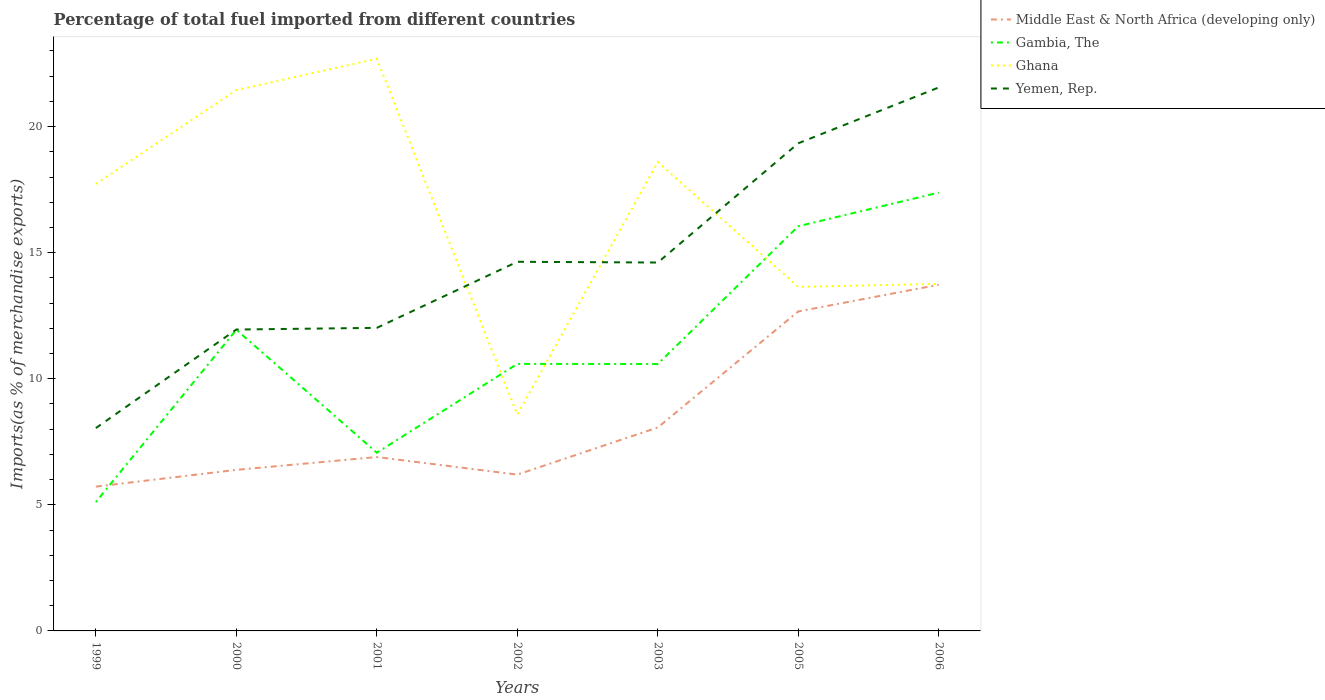Across all years, what is the maximum percentage of imports to different countries in Middle East & North Africa (developing only)?
Make the answer very short. 5.72. What is the total percentage of imports to different countries in Yemen, Rep. in the graph?
Your answer should be very brief. -0.07. What is the difference between the highest and the second highest percentage of imports to different countries in Gambia, The?
Your answer should be compact. 12.27. What is the difference between the highest and the lowest percentage of imports to different countries in Ghana?
Your answer should be compact. 4. How many lines are there?
Offer a very short reply. 4. Does the graph contain grids?
Your answer should be very brief. No. Where does the legend appear in the graph?
Provide a succinct answer. Top right. How many legend labels are there?
Ensure brevity in your answer.  4. What is the title of the graph?
Your answer should be very brief. Percentage of total fuel imported from different countries. Does "Lebanon" appear as one of the legend labels in the graph?
Keep it short and to the point. No. What is the label or title of the Y-axis?
Give a very brief answer. Imports(as % of merchandise exports). What is the Imports(as % of merchandise exports) of Middle East & North Africa (developing only) in 1999?
Offer a terse response. 5.72. What is the Imports(as % of merchandise exports) in Gambia, The in 1999?
Offer a terse response. 5.11. What is the Imports(as % of merchandise exports) in Ghana in 1999?
Keep it short and to the point. 17.73. What is the Imports(as % of merchandise exports) of Yemen, Rep. in 1999?
Keep it short and to the point. 8.04. What is the Imports(as % of merchandise exports) of Middle East & North Africa (developing only) in 2000?
Provide a short and direct response. 6.39. What is the Imports(as % of merchandise exports) in Gambia, The in 2000?
Make the answer very short. 11.94. What is the Imports(as % of merchandise exports) of Ghana in 2000?
Your response must be concise. 21.45. What is the Imports(as % of merchandise exports) of Yemen, Rep. in 2000?
Give a very brief answer. 11.95. What is the Imports(as % of merchandise exports) in Middle East & North Africa (developing only) in 2001?
Offer a very short reply. 6.9. What is the Imports(as % of merchandise exports) of Gambia, The in 2001?
Provide a succinct answer. 7.07. What is the Imports(as % of merchandise exports) in Ghana in 2001?
Your answer should be very brief. 22.69. What is the Imports(as % of merchandise exports) in Yemen, Rep. in 2001?
Provide a short and direct response. 12.02. What is the Imports(as % of merchandise exports) in Middle East & North Africa (developing only) in 2002?
Your answer should be compact. 6.2. What is the Imports(as % of merchandise exports) in Gambia, The in 2002?
Your answer should be compact. 10.59. What is the Imports(as % of merchandise exports) in Ghana in 2002?
Make the answer very short. 8.58. What is the Imports(as % of merchandise exports) in Yemen, Rep. in 2002?
Your answer should be very brief. 14.64. What is the Imports(as % of merchandise exports) of Middle East & North Africa (developing only) in 2003?
Ensure brevity in your answer.  8.07. What is the Imports(as % of merchandise exports) in Gambia, The in 2003?
Offer a very short reply. 10.59. What is the Imports(as % of merchandise exports) of Ghana in 2003?
Your answer should be compact. 18.6. What is the Imports(as % of merchandise exports) in Yemen, Rep. in 2003?
Make the answer very short. 14.61. What is the Imports(as % of merchandise exports) in Middle East & North Africa (developing only) in 2005?
Keep it short and to the point. 12.67. What is the Imports(as % of merchandise exports) in Gambia, The in 2005?
Keep it short and to the point. 16.05. What is the Imports(as % of merchandise exports) in Ghana in 2005?
Your answer should be very brief. 13.64. What is the Imports(as % of merchandise exports) in Yemen, Rep. in 2005?
Provide a succinct answer. 19.34. What is the Imports(as % of merchandise exports) in Middle East & North Africa (developing only) in 2006?
Provide a short and direct response. 13.73. What is the Imports(as % of merchandise exports) in Gambia, The in 2006?
Your answer should be compact. 17.38. What is the Imports(as % of merchandise exports) in Ghana in 2006?
Your answer should be very brief. 13.76. What is the Imports(as % of merchandise exports) in Yemen, Rep. in 2006?
Offer a very short reply. 21.55. Across all years, what is the maximum Imports(as % of merchandise exports) in Middle East & North Africa (developing only)?
Your response must be concise. 13.73. Across all years, what is the maximum Imports(as % of merchandise exports) in Gambia, The?
Give a very brief answer. 17.38. Across all years, what is the maximum Imports(as % of merchandise exports) in Ghana?
Offer a terse response. 22.69. Across all years, what is the maximum Imports(as % of merchandise exports) in Yemen, Rep.?
Your answer should be compact. 21.55. Across all years, what is the minimum Imports(as % of merchandise exports) in Middle East & North Africa (developing only)?
Make the answer very short. 5.72. Across all years, what is the minimum Imports(as % of merchandise exports) of Gambia, The?
Offer a terse response. 5.11. Across all years, what is the minimum Imports(as % of merchandise exports) in Ghana?
Give a very brief answer. 8.58. Across all years, what is the minimum Imports(as % of merchandise exports) in Yemen, Rep.?
Your answer should be compact. 8.04. What is the total Imports(as % of merchandise exports) of Middle East & North Africa (developing only) in the graph?
Offer a terse response. 59.68. What is the total Imports(as % of merchandise exports) in Gambia, The in the graph?
Offer a terse response. 78.73. What is the total Imports(as % of merchandise exports) of Ghana in the graph?
Your response must be concise. 116.45. What is the total Imports(as % of merchandise exports) of Yemen, Rep. in the graph?
Your answer should be very brief. 102.16. What is the difference between the Imports(as % of merchandise exports) of Middle East & North Africa (developing only) in 1999 and that in 2000?
Your response must be concise. -0.66. What is the difference between the Imports(as % of merchandise exports) of Gambia, The in 1999 and that in 2000?
Give a very brief answer. -6.83. What is the difference between the Imports(as % of merchandise exports) in Ghana in 1999 and that in 2000?
Give a very brief answer. -3.72. What is the difference between the Imports(as % of merchandise exports) of Yemen, Rep. in 1999 and that in 2000?
Keep it short and to the point. -3.91. What is the difference between the Imports(as % of merchandise exports) in Middle East & North Africa (developing only) in 1999 and that in 2001?
Offer a very short reply. -1.17. What is the difference between the Imports(as % of merchandise exports) of Gambia, The in 1999 and that in 2001?
Provide a succinct answer. -1.96. What is the difference between the Imports(as % of merchandise exports) of Ghana in 1999 and that in 2001?
Ensure brevity in your answer.  -4.97. What is the difference between the Imports(as % of merchandise exports) of Yemen, Rep. in 1999 and that in 2001?
Offer a very short reply. -3.97. What is the difference between the Imports(as % of merchandise exports) in Middle East & North Africa (developing only) in 1999 and that in 2002?
Ensure brevity in your answer.  -0.48. What is the difference between the Imports(as % of merchandise exports) in Gambia, The in 1999 and that in 2002?
Your answer should be compact. -5.48. What is the difference between the Imports(as % of merchandise exports) of Ghana in 1999 and that in 2002?
Offer a very short reply. 9.14. What is the difference between the Imports(as % of merchandise exports) of Yemen, Rep. in 1999 and that in 2002?
Offer a very short reply. -6.6. What is the difference between the Imports(as % of merchandise exports) in Middle East & North Africa (developing only) in 1999 and that in 2003?
Keep it short and to the point. -2.35. What is the difference between the Imports(as % of merchandise exports) in Gambia, The in 1999 and that in 2003?
Your response must be concise. -5.47. What is the difference between the Imports(as % of merchandise exports) in Ghana in 1999 and that in 2003?
Keep it short and to the point. -0.87. What is the difference between the Imports(as % of merchandise exports) in Yemen, Rep. in 1999 and that in 2003?
Provide a succinct answer. -6.57. What is the difference between the Imports(as % of merchandise exports) in Middle East & North Africa (developing only) in 1999 and that in 2005?
Provide a short and direct response. -6.95. What is the difference between the Imports(as % of merchandise exports) in Gambia, The in 1999 and that in 2005?
Make the answer very short. -10.94. What is the difference between the Imports(as % of merchandise exports) of Ghana in 1999 and that in 2005?
Give a very brief answer. 4.08. What is the difference between the Imports(as % of merchandise exports) in Yemen, Rep. in 1999 and that in 2005?
Your response must be concise. -11.3. What is the difference between the Imports(as % of merchandise exports) of Middle East & North Africa (developing only) in 1999 and that in 2006?
Keep it short and to the point. -8.01. What is the difference between the Imports(as % of merchandise exports) in Gambia, The in 1999 and that in 2006?
Your answer should be compact. -12.27. What is the difference between the Imports(as % of merchandise exports) in Ghana in 1999 and that in 2006?
Offer a very short reply. 3.96. What is the difference between the Imports(as % of merchandise exports) of Yemen, Rep. in 1999 and that in 2006?
Your answer should be very brief. -13.51. What is the difference between the Imports(as % of merchandise exports) in Middle East & North Africa (developing only) in 2000 and that in 2001?
Provide a succinct answer. -0.51. What is the difference between the Imports(as % of merchandise exports) of Gambia, The in 2000 and that in 2001?
Offer a terse response. 4.88. What is the difference between the Imports(as % of merchandise exports) in Ghana in 2000 and that in 2001?
Offer a very short reply. -1.24. What is the difference between the Imports(as % of merchandise exports) in Yemen, Rep. in 2000 and that in 2001?
Offer a terse response. -0.07. What is the difference between the Imports(as % of merchandise exports) in Middle East & North Africa (developing only) in 2000 and that in 2002?
Offer a very short reply. 0.19. What is the difference between the Imports(as % of merchandise exports) of Gambia, The in 2000 and that in 2002?
Provide a succinct answer. 1.35. What is the difference between the Imports(as % of merchandise exports) of Ghana in 2000 and that in 2002?
Your response must be concise. 12.87. What is the difference between the Imports(as % of merchandise exports) of Yemen, Rep. in 2000 and that in 2002?
Keep it short and to the point. -2.69. What is the difference between the Imports(as % of merchandise exports) in Middle East & North Africa (developing only) in 2000 and that in 2003?
Provide a short and direct response. -1.68. What is the difference between the Imports(as % of merchandise exports) in Gambia, The in 2000 and that in 2003?
Ensure brevity in your answer.  1.36. What is the difference between the Imports(as % of merchandise exports) of Ghana in 2000 and that in 2003?
Make the answer very short. 2.85. What is the difference between the Imports(as % of merchandise exports) of Yemen, Rep. in 2000 and that in 2003?
Offer a very short reply. -2.66. What is the difference between the Imports(as % of merchandise exports) in Middle East & North Africa (developing only) in 2000 and that in 2005?
Offer a terse response. -6.28. What is the difference between the Imports(as % of merchandise exports) of Gambia, The in 2000 and that in 2005?
Provide a short and direct response. -4.11. What is the difference between the Imports(as % of merchandise exports) of Ghana in 2000 and that in 2005?
Your answer should be compact. 7.8. What is the difference between the Imports(as % of merchandise exports) in Yemen, Rep. in 2000 and that in 2005?
Provide a succinct answer. -7.39. What is the difference between the Imports(as % of merchandise exports) of Middle East & North Africa (developing only) in 2000 and that in 2006?
Your response must be concise. -7.34. What is the difference between the Imports(as % of merchandise exports) in Gambia, The in 2000 and that in 2006?
Provide a succinct answer. -5.44. What is the difference between the Imports(as % of merchandise exports) of Ghana in 2000 and that in 2006?
Make the answer very short. 7.68. What is the difference between the Imports(as % of merchandise exports) of Yemen, Rep. in 2000 and that in 2006?
Keep it short and to the point. -9.6. What is the difference between the Imports(as % of merchandise exports) of Middle East & North Africa (developing only) in 2001 and that in 2002?
Make the answer very short. 0.7. What is the difference between the Imports(as % of merchandise exports) in Gambia, The in 2001 and that in 2002?
Offer a terse response. -3.52. What is the difference between the Imports(as % of merchandise exports) in Ghana in 2001 and that in 2002?
Your answer should be compact. 14.11. What is the difference between the Imports(as % of merchandise exports) in Yemen, Rep. in 2001 and that in 2002?
Your answer should be compact. -2.62. What is the difference between the Imports(as % of merchandise exports) of Middle East & North Africa (developing only) in 2001 and that in 2003?
Provide a short and direct response. -1.17. What is the difference between the Imports(as % of merchandise exports) of Gambia, The in 2001 and that in 2003?
Ensure brevity in your answer.  -3.52. What is the difference between the Imports(as % of merchandise exports) in Ghana in 2001 and that in 2003?
Provide a succinct answer. 4.1. What is the difference between the Imports(as % of merchandise exports) in Yemen, Rep. in 2001 and that in 2003?
Offer a very short reply. -2.59. What is the difference between the Imports(as % of merchandise exports) of Middle East & North Africa (developing only) in 2001 and that in 2005?
Offer a very short reply. -5.77. What is the difference between the Imports(as % of merchandise exports) of Gambia, The in 2001 and that in 2005?
Your answer should be very brief. -8.98. What is the difference between the Imports(as % of merchandise exports) in Ghana in 2001 and that in 2005?
Your response must be concise. 9.05. What is the difference between the Imports(as % of merchandise exports) of Yemen, Rep. in 2001 and that in 2005?
Give a very brief answer. -7.32. What is the difference between the Imports(as % of merchandise exports) in Middle East & North Africa (developing only) in 2001 and that in 2006?
Provide a succinct answer. -6.83. What is the difference between the Imports(as % of merchandise exports) of Gambia, The in 2001 and that in 2006?
Make the answer very short. -10.31. What is the difference between the Imports(as % of merchandise exports) in Ghana in 2001 and that in 2006?
Your answer should be very brief. 8.93. What is the difference between the Imports(as % of merchandise exports) in Yemen, Rep. in 2001 and that in 2006?
Your answer should be very brief. -9.53. What is the difference between the Imports(as % of merchandise exports) in Middle East & North Africa (developing only) in 2002 and that in 2003?
Your answer should be very brief. -1.87. What is the difference between the Imports(as % of merchandise exports) in Gambia, The in 2002 and that in 2003?
Keep it short and to the point. 0. What is the difference between the Imports(as % of merchandise exports) of Ghana in 2002 and that in 2003?
Your answer should be compact. -10.01. What is the difference between the Imports(as % of merchandise exports) in Yemen, Rep. in 2002 and that in 2003?
Provide a short and direct response. 0.03. What is the difference between the Imports(as % of merchandise exports) of Middle East & North Africa (developing only) in 2002 and that in 2005?
Give a very brief answer. -6.47. What is the difference between the Imports(as % of merchandise exports) in Gambia, The in 2002 and that in 2005?
Make the answer very short. -5.46. What is the difference between the Imports(as % of merchandise exports) in Ghana in 2002 and that in 2005?
Your answer should be very brief. -5.06. What is the difference between the Imports(as % of merchandise exports) of Yemen, Rep. in 2002 and that in 2005?
Ensure brevity in your answer.  -4.7. What is the difference between the Imports(as % of merchandise exports) of Middle East & North Africa (developing only) in 2002 and that in 2006?
Your response must be concise. -7.53. What is the difference between the Imports(as % of merchandise exports) of Gambia, The in 2002 and that in 2006?
Offer a terse response. -6.79. What is the difference between the Imports(as % of merchandise exports) in Ghana in 2002 and that in 2006?
Offer a very short reply. -5.18. What is the difference between the Imports(as % of merchandise exports) in Yemen, Rep. in 2002 and that in 2006?
Ensure brevity in your answer.  -6.91. What is the difference between the Imports(as % of merchandise exports) of Middle East & North Africa (developing only) in 2003 and that in 2005?
Your answer should be very brief. -4.6. What is the difference between the Imports(as % of merchandise exports) of Gambia, The in 2003 and that in 2005?
Give a very brief answer. -5.47. What is the difference between the Imports(as % of merchandise exports) of Ghana in 2003 and that in 2005?
Your answer should be compact. 4.95. What is the difference between the Imports(as % of merchandise exports) of Yemen, Rep. in 2003 and that in 2005?
Your response must be concise. -4.73. What is the difference between the Imports(as % of merchandise exports) in Middle East & North Africa (developing only) in 2003 and that in 2006?
Provide a succinct answer. -5.66. What is the difference between the Imports(as % of merchandise exports) of Gambia, The in 2003 and that in 2006?
Provide a short and direct response. -6.8. What is the difference between the Imports(as % of merchandise exports) in Ghana in 2003 and that in 2006?
Your answer should be very brief. 4.83. What is the difference between the Imports(as % of merchandise exports) of Yemen, Rep. in 2003 and that in 2006?
Your answer should be very brief. -6.94. What is the difference between the Imports(as % of merchandise exports) in Middle East & North Africa (developing only) in 2005 and that in 2006?
Provide a short and direct response. -1.06. What is the difference between the Imports(as % of merchandise exports) of Gambia, The in 2005 and that in 2006?
Make the answer very short. -1.33. What is the difference between the Imports(as % of merchandise exports) in Ghana in 2005 and that in 2006?
Make the answer very short. -0.12. What is the difference between the Imports(as % of merchandise exports) in Yemen, Rep. in 2005 and that in 2006?
Your response must be concise. -2.21. What is the difference between the Imports(as % of merchandise exports) in Middle East & North Africa (developing only) in 1999 and the Imports(as % of merchandise exports) in Gambia, The in 2000?
Your answer should be very brief. -6.22. What is the difference between the Imports(as % of merchandise exports) in Middle East & North Africa (developing only) in 1999 and the Imports(as % of merchandise exports) in Ghana in 2000?
Keep it short and to the point. -15.72. What is the difference between the Imports(as % of merchandise exports) in Middle East & North Africa (developing only) in 1999 and the Imports(as % of merchandise exports) in Yemen, Rep. in 2000?
Keep it short and to the point. -6.23. What is the difference between the Imports(as % of merchandise exports) in Gambia, The in 1999 and the Imports(as % of merchandise exports) in Ghana in 2000?
Give a very brief answer. -16.34. What is the difference between the Imports(as % of merchandise exports) in Gambia, The in 1999 and the Imports(as % of merchandise exports) in Yemen, Rep. in 2000?
Your answer should be very brief. -6.84. What is the difference between the Imports(as % of merchandise exports) of Ghana in 1999 and the Imports(as % of merchandise exports) of Yemen, Rep. in 2000?
Ensure brevity in your answer.  5.77. What is the difference between the Imports(as % of merchandise exports) of Middle East & North Africa (developing only) in 1999 and the Imports(as % of merchandise exports) of Gambia, The in 2001?
Your answer should be compact. -1.34. What is the difference between the Imports(as % of merchandise exports) of Middle East & North Africa (developing only) in 1999 and the Imports(as % of merchandise exports) of Ghana in 2001?
Give a very brief answer. -16.97. What is the difference between the Imports(as % of merchandise exports) of Middle East & North Africa (developing only) in 1999 and the Imports(as % of merchandise exports) of Yemen, Rep. in 2001?
Provide a short and direct response. -6.3. What is the difference between the Imports(as % of merchandise exports) in Gambia, The in 1999 and the Imports(as % of merchandise exports) in Ghana in 2001?
Give a very brief answer. -17.58. What is the difference between the Imports(as % of merchandise exports) of Gambia, The in 1999 and the Imports(as % of merchandise exports) of Yemen, Rep. in 2001?
Provide a succinct answer. -6.91. What is the difference between the Imports(as % of merchandise exports) in Ghana in 1999 and the Imports(as % of merchandise exports) in Yemen, Rep. in 2001?
Your response must be concise. 5.71. What is the difference between the Imports(as % of merchandise exports) of Middle East & North Africa (developing only) in 1999 and the Imports(as % of merchandise exports) of Gambia, The in 2002?
Offer a very short reply. -4.87. What is the difference between the Imports(as % of merchandise exports) in Middle East & North Africa (developing only) in 1999 and the Imports(as % of merchandise exports) in Ghana in 2002?
Give a very brief answer. -2.86. What is the difference between the Imports(as % of merchandise exports) of Middle East & North Africa (developing only) in 1999 and the Imports(as % of merchandise exports) of Yemen, Rep. in 2002?
Ensure brevity in your answer.  -8.92. What is the difference between the Imports(as % of merchandise exports) of Gambia, The in 1999 and the Imports(as % of merchandise exports) of Ghana in 2002?
Provide a short and direct response. -3.47. What is the difference between the Imports(as % of merchandise exports) of Gambia, The in 1999 and the Imports(as % of merchandise exports) of Yemen, Rep. in 2002?
Give a very brief answer. -9.53. What is the difference between the Imports(as % of merchandise exports) of Ghana in 1999 and the Imports(as % of merchandise exports) of Yemen, Rep. in 2002?
Provide a short and direct response. 3.09. What is the difference between the Imports(as % of merchandise exports) in Middle East & North Africa (developing only) in 1999 and the Imports(as % of merchandise exports) in Gambia, The in 2003?
Provide a succinct answer. -4.86. What is the difference between the Imports(as % of merchandise exports) in Middle East & North Africa (developing only) in 1999 and the Imports(as % of merchandise exports) in Ghana in 2003?
Give a very brief answer. -12.87. What is the difference between the Imports(as % of merchandise exports) of Middle East & North Africa (developing only) in 1999 and the Imports(as % of merchandise exports) of Yemen, Rep. in 2003?
Your response must be concise. -8.89. What is the difference between the Imports(as % of merchandise exports) in Gambia, The in 1999 and the Imports(as % of merchandise exports) in Ghana in 2003?
Ensure brevity in your answer.  -13.48. What is the difference between the Imports(as % of merchandise exports) in Gambia, The in 1999 and the Imports(as % of merchandise exports) in Yemen, Rep. in 2003?
Offer a very short reply. -9.5. What is the difference between the Imports(as % of merchandise exports) of Ghana in 1999 and the Imports(as % of merchandise exports) of Yemen, Rep. in 2003?
Ensure brevity in your answer.  3.12. What is the difference between the Imports(as % of merchandise exports) in Middle East & North Africa (developing only) in 1999 and the Imports(as % of merchandise exports) in Gambia, The in 2005?
Keep it short and to the point. -10.33. What is the difference between the Imports(as % of merchandise exports) in Middle East & North Africa (developing only) in 1999 and the Imports(as % of merchandise exports) in Ghana in 2005?
Your response must be concise. -7.92. What is the difference between the Imports(as % of merchandise exports) in Middle East & North Africa (developing only) in 1999 and the Imports(as % of merchandise exports) in Yemen, Rep. in 2005?
Provide a succinct answer. -13.62. What is the difference between the Imports(as % of merchandise exports) in Gambia, The in 1999 and the Imports(as % of merchandise exports) in Ghana in 2005?
Offer a terse response. -8.53. What is the difference between the Imports(as % of merchandise exports) in Gambia, The in 1999 and the Imports(as % of merchandise exports) in Yemen, Rep. in 2005?
Ensure brevity in your answer.  -14.23. What is the difference between the Imports(as % of merchandise exports) in Ghana in 1999 and the Imports(as % of merchandise exports) in Yemen, Rep. in 2005?
Offer a terse response. -1.61. What is the difference between the Imports(as % of merchandise exports) in Middle East & North Africa (developing only) in 1999 and the Imports(as % of merchandise exports) in Gambia, The in 2006?
Make the answer very short. -11.66. What is the difference between the Imports(as % of merchandise exports) in Middle East & North Africa (developing only) in 1999 and the Imports(as % of merchandise exports) in Ghana in 2006?
Your answer should be very brief. -8.04. What is the difference between the Imports(as % of merchandise exports) in Middle East & North Africa (developing only) in 1999 and the Imports(as % of merchandise exports) in Yemen, Rep. in 2006?
Your response must be concise. -15.83. What is the difference between the Imports(as % of merchandise exports) of Gambia, The in 1999 and the Imports(as % of merchandise exports) of Ghana in 2006?
Keep it short and to the point. -8.65. What is the difference between the Imports(as % of merchandise exports) of Gambia, The in 1999 and the Imports(as % of merchandise exports) of Yemen, Rep. in 2006?
Offer a terse response. -16.44. What is the difference between the Imports(as % of merchandise exports) in Ghana in 1999 and the Imports(as % of merchandise exports) in Yemen, Rep. in 2006?
Provide a succinct answer. -3.83. What is the difference between the Imports(as % of merchandise exports) in Middle East & North Africa (developing only) in 2000 and the Imports(as % of merchandise exports) in Gambia, The in 2001?
Your response must be concise. -0.68. What is the difference between the Imports(as % of merchandise exports) in Middle East & North Africa (developing only) in 2000 and the Imports(as % of merchandise exports) in Ghana in 2001?
Give a very brief answer. -16.3. What is the difference between the Imports(as % of merchandise exports) in Middle East & North Africa (developing only) in 2000 and the Imports(as % of merchandise exports) in Yemen, Rep. in 2001?
Your response must be concise. -5.63. What is the difference between the Imports(as % of merchandise exports) in Gambia, The in 2000 and the Imports(as % of merchandise exports) in Ghana in 2001?
Keep it short and to the point. -10.75. What is the difference between the Imports(as % of merchandise exports) in Gambia, The in 2000 and the Imports(as % of merchandise exports) in Yemen, Rep. in 2001?
Your answer should be compact. -0.08. What is the difference between the Imports(as % of merchandise exports) in Ghana in 2000 and the Imports(as % of merchandise exports) in Yemen, Rep. in 2001?
Offer a very short reply. 9.43. What is the difference between the Imports(as % of merchandise exports) of Middle East & North Africa (developing only) in 2000 and the Imports(as % of merchandise exports) of Gambia, The in 2002?
Make the answer very short. -4.2. What is the difference between the Imports(as % of merchandise exports) of Middle East & North Africa (developing only) in 2000 and the Imports(as % of merchandise exports) of Ghana in 2002?
Give a very brief answer. -2.19. What is the difference between the Imports(as % of merchandise exports) in Middle East & North Africa (developing only) in 2000 and the Imports(as % of merchandise exports) in Yemen, Rep. in 2002?
Offer a terse response. -8.25. What is the difference between the Imports(as % of merchandise exports) in Gambia, The in 2000 and the Imports(as % of merchandise exports) in Ghana in 2002?
Make the answer very short. 3.36. What is the difference between the Imports(as % of merchandise exports) of Gambia, The in 2000 and the Imports(as % of merchandise exports) of Yemen, Rep. in 2002?
Your answer should be compact. -2.7. What is the difference between the Imports(as % of merchandise exports) in Ghana in 2000 and the Imports(as % of merchandise exports) in Yemen, Rep. in 2002?
Offer a very short reply. 6.81. What is the difference between the Imports(as % of merchandise exports) in Middle East & North Africa (developing only) in 2000 and the Imports(as % of merchandise exports) in Gambia, The in 2003?
Provide a succinct answer. -4.2. What is the difference between the Imports(as % of merchandise exports) of Middle East & North Africa (developing only) in 2000 and the Imports(as % of merchandise exports) of Ghana in 2003?
Provide a short and direct response. -12.21. What is the difference between the Imports(as % of merchandise exports) in Middle East & North Africa (developing only) in 2000 and the Imports(as % of merchandise exports) in Yemen, Rep. in 2003?
Ensure brevity in your answer.  -8.22. What is the difference between the Imports(as % of merchandise exports) in Gambia, The in 2000 and the Imports(as % of merchandise exports) in Ghana in 2003?
Give a very brief answer. -6.65. What is the difference between the Imports(as % of merchandise exports) in Gambia, The in 2000 and the Imports(as % of merchandise exports) in Yemen, Rep. in 2003?
Provide a succinct answer. -2.67. What is the difference between the Imports(as % of merchandise exports) of Ghana in 2000 and the Imports(as % of merchandise exports) of Yemen, Rep. in 2003?
Offer a very short reply. 6.84. What is the difference between the Imports(as % of merchandise exports) in Middle East & North Africa (developing only) in 2000 and the Imports(as % of merchandise exports) in Gambia, The in 2005?
Make the answer very short. -9.66. What is the difference between the Imports(as % of merchandise exports) of Middle East & North Africa (developing only) in 2000 and the Imports(as % of merchandise exports) of Ghana in 2005?
Make the answer very short. -7.26. What is the difference between the Imports(as % of merchandise exports) of Middle East & North Africa (developing only) in 2000 and the Imports(as % of merchandise exports) of Yemen, Rep. in 2005?
Ensure brevity in your answer.  -12.95. What is the difference between the Imports(as % of merchandise exports) of Gambia, The in 2000 and the Imports(as % of merchandise exports) of Ghana in 2005?
Keep it short and to the point. -1.7. What is the difference between the Imports(as % of merchandise exports) in Gambia, The in 2000 and the Imports(as % of merchandise exports) in Yemen, Rep. in 2005?
Ensure brevity in your answer.  -7.4. What is the difference between the Imports(as % of merchandise exports) in Ghana in 2000 and the Imports(as % of merchandise exports) in Yemen, Rep. in 2005?
Provide a short and direct response. 2.11. What is the difference between the Imports(as % of merchandise exports) of Middle East & North Africa (developing only) in 2000 and the Imports(as % of merchandise exports) of Gambia, The in 2006?
Your answer should be compact. -10.99. What is the difference between the Imports(as % of merchandise exports) of Middle East & North Africa (developing only) in 2000 and the Imports(as % of merchandise exports) of Ghana in 2006?
Make the answer very short. -7.38. What is the difference between the Imports(as % of merchandise exports) of Middle East & North Africa (developing only) in 2000 and the Imports(as % of merchandise exports) of Yemen, Rep. in 2006?
Offer a terse response. -15.17. What is the difference between the Imports(as % of merchandise exports) of Gambia, The in 2000 and the Imports(as % of merchandise exports) of Ghana in 2006?
Keep it short and to the point. -1.82. What is the difference between the Imports(as % of merchandise exports) of Gambia, The in 2000 and the Imports(as % of merchandise exports) of Yemen, Rep. in 2006?
Give a very brief answer. -9.61. What is the difference between the Imports(as % of merchandise exports) in Ghana in 2000 and the Imports(as % of merchandise exports) in Yemen, Rep. in 2006?
Provide a succinct answer. -0.11. What is the difference between the Imports(as % of merchandise exports) in Middle East & North Africa (developing only) in 2001 and the Imports(as % of merchandise exports) in Gambia, The in 2002?
Make the answer very short. -3.69. What is the difference between the Imports(as % of merchandise exports) in Middle East & North Africa (developing only) in 2001 and the Imports(as % of merchandise exports) in Ghana in 2002?
Your response must be concise. -1.69. What is the difference between the Imports(as % of merchandise exports) of Middle East & North Africa (developing only) in 2001 and the Imports(as % of merchandise exports) of Yemen, Rep. in 2002?
Your answer should be very brief. -7.74. What is the difference between the Imports(as % of merchandise exports) in Gambia, The in 2001 and the Imports(as % of merchandise exports) in Ghana in 2002?
Keep it short and to the point. -1.51. What is the difference between the Imports(as % of merchandise exports) in Gambia, The in 2001 and the Imports(as % of merchandise exports) in Yemen, Rep. in 2002?
Your response must be concise. -7.57. What is the difference between the Imports(as % of merchandise exports) of Ghana in 2001 and the Imports(as % of merchandise exports) of Yemen, Rep. in 2002?
Offer a very short reply. 8.05. What is the difference between the Imports(as % of merchandise exports) of Middle East & North Africa (developing only) in 2001 and the Imports(as % of merchandise exports) of Gambia, The in 2003?
Provide a short and direct response. -3.69. What is the difference between the Imports(as % of merchandise exports) of Middle East & North Africa (developing only) in 2001 and the Imports(as % of merchandise exports) of Ghana in 2003?
Ensure brevity in your answer.  -11.7. What is the difference between the Imports(as % of merchandise exports) of Middle East & North Africa (developing only) in 2001 and the Imports(as % of merchandise exports) of Yemen, Rep. in 2003?
Provide a succinct answer. -7.71. What is the difference between the Imports(as % of merchandise exports) of Gambia, The in 2001 and the Imports(as % of merchandise exports) of Ghana in 2003?
Offer a terse response. -11.53. What is the difference between the Imports(as % of merchandise exports) of Gambia, The in 2001 and the Imports(as % of merchandise exports) of Yemen, Rep. in 2003?
Give a very brief answer. -7.54. What is the difference between the Imports(as % of merchandise exports) of Ghana in 2001 and the Imports(as % of merchandise exports) of Yemen, Rep. in 2003?
Offer a terse response. 8.08. What is the difference between the Imports(as % of merchandise exports) in Middle East & North Africa (developing only) in 2001 and the Imports(as % of merchandise exports) in Gambia, The in 2005?
Your answer should be very brief. -9.15. What is the difference between the Imports(as % of merchandise exports) of Middle East & North Africa (developing only) in 2001 and the Imports(as % of merchandise exports) of Ghana in 2005?
Your answer should be very brief. -6.75. What is the difference between the Imports(as % of merchandise exports) of Middle East & North Africa (developing only) in 2001 and the Imports(as % of merchandise exports) of Yemen, Rep. in 2005?
Keep it short and to the point. -12.44. What is the difference between the Imports(as % of merchandise exports) in Gambia, The in 2001 and the Imports(as % of merchandise exports) in Ghana in 2005?
Offer a terse response. -6.58. What is the difference between the Imports(as % of merchandise exports) in Gambia, The in 2001 and the Imports(as % of merchandise exports) in Yemen, Rep. in 2005?
Offer a very short reply. -12.27. What is the difference between the Imports(as % of merchandise exports) of Ghana in 2001 and the Imports(as % of merchandise exports) of Yemen, Rep. in 2005?
Keep it short and to the point. 3.35. What is the difference between the Imports(as % of merchandise exports) of Middle East & North Africa (developing only) in 2001 and the Imports(as % of merchandise exports) of Gambia, The in 2006?
Provide a short and direct response. -10.49. What is the difference between the Imports(as % of merchandise exports) of Middle East & North Africa (developing only) in 2001 and the Imports(as % of merchandise exports) of Ghana in 2006?
Make the answer very short. -6.87. What is the difference between the Imports(as % of merchandise exports) in Middle East & North Africa (developing only) in 2001 and the Imports(as % of merchandise exports) in Yemen, Rep. in 2006?
Ensure brevity in your answer.  -14.66. What is the difference between the Imports(as % of merchandise exports) in Gambia, The in 2001 and the Imports(as % of merchandise exports) in Ghana in 2006?
Provide a short and direct response. -6.7. What is the difference between the Imports(as % of merchandise exports) in Gambia, The in 2001 and the Imports(as % of merchandise exports) in Yemen, Rep. in 2006?
Your response must be concise. -14.49. What is the difference between the Imports(as % of merchandise exports) in Ghana in 2001 and the Imports(as % of merchandise exports) in Yemen, Rep. in 2006?
Ensure brevity in your answer.  1.14. What is the difference between the Imports(as % of merchandise exports) of Middle East & North Africa (developing only) in 2002 and the Imports(as % of merchandise exports) of Gambia, The in 2003?
Your answer should be very brief. -4.39. What is the difference between the Imports(as % of merchandise exports) of Middle East & North Africa (developing only) in 2002 and the Imports(as % of merchandise exports) of Ghana in 2003?
Provide a succinct answer. -12.4. What is the difference between the Imports(as % of merchandise exports) in Middle East & North Africa (developing only) in 2002 and the Imports(as % of merchandise exports) in Yemen, Rep. in 2003?
Your answer should be very brief. -8.41. What is the difference between the Imports(as % of merchandise exports) in Gambia, The in 2002 and the Imports(as % of merchandise exports) in Ghana in 2003?
Offer a very short reply. -8.01. What is the difference between the Imports(as % of merchandise exports) in Gambia, The in 2002 and the Imports(as % of merchandise exports) in Yemen, Rep. in 2003?
Offer a terse response. -4.02. What is the difference between the Imports(as % of merchandise exports) in Ghana in 2002 and the Imports(as % of merchandise exports) in Yemen, Rep. in 2003?
Your answer should be compact. -6.03. What is the difference between the Imports(as % of merchandise exports) of Middle East & North Africa (developing only) in 2002 and the Imports(as % of merchandise exports) of Gambia, The in 2005?
Make the answer very short. -9.85. What is the difference between the Imports(as % of merchandise exports) in Middle East & North Africa (developing only) in 2002 and the Imports(as % of merchandise exports) in Ghana in 2005?
Provide a succinct answer. -7.44. What is the difference between the Imports(as % of merchandise exports) of Middle East & North Africa (developing only) in 2002 and the Imports(as % of merchandise exports) of Yemen, Rep. in 2005?
Your answer should be compact. -13.14. What is the difference between the Imports(as % of merchandise exports) in Gambia, The in 2002 and the Imports(as % of merchandise exports) in Ghana in 2005?
Offer a terse response. -3.05. What is the difference between the Imports(as % of merchandise exports) in Gambia, The in 2002 and the Imports(as % of merchandise exports) in Yemen, Rep. in 2005?
Your response must be concise. -8.75. What is the difference between the Imports(as % of merchandise exports) in Ghana in 2002 and the Imports(as % of merchandise exports) in Yemen, Rep. in 2005?
Your response must be concise. -10.76. What is the difference between the Imports(as % of merchandise exports) of Middle East & North Africa (developing only) in 2002 and the Imports(as % of merchandise exports) of Gambia, The in 2006?
Provide a short and direct response. -11.18. What is the difference between the Imports(as % of merchandise exports) of Middle East & North Africa (developing only) in 2002 and the Imports(as % of merchandise exports) of Ghana in 2006?
Offer a terse response. -7.56. What is the difference between the Imports(as % of merchandise exports) in Middle East & North Africa (developing only) in 2002 and the Imports(as % of merchandise exports) in Yemen, Rep. in 2006?
Make the answer very short. -15.35. What is the difference between the Imports(as % of merchandise exports) of Gambia, The in 2002 and the Imports(as % of merchandise exports) of Ghana in 2006?
Offer a terse response. -3.17. What is the difference between the Imports(as % of merchandise exports) in Gambia, The in 2002 and the Imports(as % of merchandise exports) in Yemen, Rep. in 2006?
Ensure brevity in your answer.  -10.96. What is the difference between the Imports(as % of merchandise exports) of Ghana in 2002 and the Imports(as % of merchandise exports) of Yemen, Rep. in 2006?
Keep it short and to the point. -12.97. What is the difference between the Imports(as % of merchandise exports) in Middle East & North Africa (developing only) in 2003 and the Imports(as % of merchandise exports) in Gambia, The in 2005?
Your response must be concise. -7.98. What is the difference between the Imports(as % of merchandise exports) in Middle East & North Africa (developing only) in 2003 and the Imports(as % of merchandise exports) in Ghana in 2005?
Make the answer very short. -5.57. What is the difference between the Imports(as % of merchandise exports) of Middle East & North Africa (developing only) in 2003 and the Imports(as % of merchandise exports) of Yemen, Rep. in 2005?
Give a very brief answer. -11.27. What is the difference between the Imports(as % of merchandise exports) in Gambia, The in 2003 and the Imports(as % of merchandise exports) in Ghana in 2005?
Provide a short and direct response. -3.06. What is the difference between the Imports(as % of merchandise exports) in Gambia, The in 2003 and the Imports(as % of merchandise exports) in Yemen, Rep. in 2005?
Make the answer very short. -8.76. What is the difference between the Imports(as % of merchandise exports) of Ghana in 2003 and the Imports(as % of merchandise exports) of Yemen, Rep. in 2005?
Keep it short and to the point. -0.74. What is the difference between the Imports(as % of merchandise exports) of Middle East & North Africa (developing only) in 2003 and the Imports(as % of merchandise exports) of Gambia, The in 2006?
Keep it short and to the point. -9.31. What is the difference between the Imports(as % of merchandise exports) of Middle East & North Africa (developing only) in 2003 and the Imports(as % of merchandise exports) of Ghana in 2006?
Provide a succinct answer. -5.69. What is the difference between the Imports(as % of merchandise exports) in Middle East & North Africa (developing only) in 2003 and the Imports(as % of merchandise exports) in Yemen, Rep. in 2006?
Your response must be concise. -13.48. What is the difference between the Imports(as % of merchandise exports) in Gambia, The in 2003 and the Imports(as % of merchandise exports) in Ghana in 2006?
Provide a succinct answer. -3.18. What is the difference between the Imports(as % of merchandise exports) of Gambia, The in 2003 and the Imports(as % of merchandise exports) of Yemen, Rep. in 2006?
Provide a succinct answer. -10.97. What is the difference between the Imports(as % of merchandise exports) of Ghana in 2003 and the Imports(as % of merchandise exports) of Yemen, Rep. in 2006?
Provide a short and direct response. -2.96. What is the difference between the Imports(as % of merchandise exports) in Middle East & North Africa (developing only) in 2005 and the Imports(as % of merchandise exports) in Gambia, The in 2006?
Offer a terse response. -4.71. What is the difference between the Imports(as % of merchandise exports) of Middle East & North Africa (developing only) in 2005 and the Imports(as % of merchandise exports) of Ghana in 2006?
Keep it short and to the point. -1.09. What is the difference between the Imports(as % of merchandise exports) of Middle East & North Africa (developing only) in 2005 and the Imports(as % of merchandise exports) of Yemen, Rep. in 2006?
Offer a terse response. -8.88. What is the difference between the Imports(as % of merchandise exports) of Gambia, The in 2005 and the Imports(as % of merchandise exports) of Ghana in 2006?
Give a very brief answer. 2.29. What is the difference between the Imports(as % of merchandise exports) in Gambia, The in 2005 and the Imports(as % of merchandise exports) in Yemen, Rep. in 2006?
Your response must be concise. -5.5. What is the difference between the Imports(as % of merchandise exports) of Ghana in 2005 and the Imports(as % of merchandise exports) of Yemen, Rep. in 2006?
Your answer should be compact. -7.91. What is the average Imports(as % of merchandise exports) in Middle East & North Africa (developing only) per year?
Your answer should be very brief. 8.53. What is the average Imports(as % of merchandise exports) of Gambia, The per year?
Make the answer very short. 11.25. What is the average Imports(as % of merchandise exports) in Ghana per year?
Offer a terse response. 16.64. What is the average Imports(as % of merchandise exports) of Yemen, Rep. per year?
Give a very brief answer. 14.59. In the year 1999, what is the difference between the Imports(as % of merchandise exports) in Middle East & North Africa (developing only) and Imports(as % of merchandise exports) in Gambia, The?
Keep it short and to the point. 0.61. In the year 1999, what is the difference between the Imports(as % of merchandise exports) of Middle East & North Africa (developing only) and Imports(as % of merchandise exports) of Ghana?
Ensure brevity in your answer.  -12. In the year 1999, what is the difference between the Imports(as % of merchandise exports) in Middle East & North Africa (developing only) and Imports(as % of merchandise exports) in Yemen, Rep.?
Provide a succinct answer. -2.32. In the year 1999, what is the difference between the Imports(as % of merchandise exports) of Gambia, The and Imports(as % of merchandise exports) of Ghana?
Offer a very short reply. -12.61. In the year 1999, what is the difference between the Imports(as % of merchandise exports) in Gambia, The and Imports(as % of merchandise exports) in Yemen, Rep.?
Make the answer very short. -2.93. In the year 1999, what is the difference between the Imports(as % of merchandise exports) in Ghana and Imports(as % of merchandise exports) in Yemen, Rep.?
Make the answer very short. 9.68. In the year 2000, what is the difference between the Imports(as % of merchandise exports) in Middle East & North Africa (developing only) and Imports(as % of merchandise exports) in Gambia, The?
Provide a succinct answer. -5.56. In the year 2000, what is the difference between the Imports(as % of merchandise exports) in Middle East & North Africa (developing only) and Imports(as % of merchandise exports) in Ghana?
Give a very brief answer. -15.06. In the year 2000, what is the difference between the Imports(as % of merchandise exports) in Middle East & North Africa (developing only) and Imports(as % of merchandise exports) in Yemen, Rep.?
Your answer should be compact. -5.57. In the year 2000, what is the difference between the Imports(as % of merchandise exports) of Gambia, The and Imports(as % of merchandise exports) of Ghana?
Your answer should be compact. -9.5. In the year 2000, what is the difference between the Imports(as % of merchandise exports) in Gambia, The and Imports(as % of merchandise exports) in Yemen, Rep.?
Your response must be concise. -0.01. In the year 2000, what is the difference between the Imports(as % of merchandise exports) in Ghana and Imports(as % of merchandise exports) in Yemen, Rep.?
Offer a very short reply. 9.49. In the year 2001, what is the difference between the Imports(as % of merchandise exports) of Middle East & North Africa (developing only) and Imports(as % of merchandise exports) of Gambia, The?
Keep it short and to the point. -0.17. In the year 2001, what is the difference between the Imports(as % of merchandise exports) in Middle East & North Africa (developing only) and Imports(as % of merchandise exports) in Ghana?
Your answer should be compact. -15.8. In the year 2001, what is the difference between the Imports(as % of merchandise exports) in Middle East & North Africa (developing only) and Imports(as % of merchandise exports) in Yemen, Rep.?
Your answer should be compact. -5.12. In the year 2001, what is the difference between the Imports(as % of merchandise exports) in Gambia, The and Imports(as % of merchandise exports) in Ghana?
Provide a succinct answer. -15.62. In the year 2001, what is the difference between the Imports(as % of merchandise exports) in Gambia, The and Imports(as % of merchandise exports) in Yemen, Rep.?
Ensure brevity in your answer.  -4.95. In the year 2001, what is the difference between the Imports(as % of merchandise exports) in Ghana and Imports(as % of merchandise exports) in Yemen, Rep.?
Offer a very short reply. 10.67. In the year 2002, what is the difference between the Imports(as % of merchandise exports) in Middle East & North Africa (developing only) and Imports(as % of merchandise exports) in Gambia, The?
Your answer should be compact. -4.39. In the year 2002, what is the difference between the Imports(as % of merchandise exports) of Middle East & North Africa (developing only) and Imports(as % of merchandise exports) of Ghana?
Provide a succinct answer. -2.38. In the year 2002, what is the difference between the Imports(as % of merchandise exports) in Middle East & North Africa (developing only) and Imports(as % of merchandise exports) in Yemen, Rep.?
Offer a terse response. -8.44. In the year 2002, what is the difference between the Imports(as % of merchandise exports) of Gambia, The and Imports(as % of merchandise exports) of Ghana?
Your answer should be very brief. 2.01. In the year 2002, what is the difference between the Imports(as % of merchandise exports) of Gambia, The and Imports(as % of merchandise exports) of Yemen, Rep.?
Make the answer very short. -4.05. In the year 2002, what is the difference between the Imports(as % of merchandise exports) in Ghana and Imports(as % of merchandise exports) in Yemen, Rep.?
Your response must be concise. -6.06. In the year 2003, what is the difference between the Imports(as % of merchandise exports) in Middle East & North Africa (developing only) and Imports(as % of merchandise exports) in Gambia, The?
Provide a short and direct response. -2.52. In the year 2003, what is the difference between the Imports(as % of merchandise exports) in Middle East & North Africa (developing only) and Imports(as % of merchandise exports) in Ghana?
Your answer should be very brief. -10.53. In the year 2003, what is the difference between the Imports(as % of merchandise exports) in Middle East & North Africa (developing only) and Imports(as % of merchandise exports) in Yemen, Rep.?
Your answer should be compact. -6.54. In the year 2003, what is the difference between the Imports(as % of merchandise exports) of Gambia, The and Imports(as % of merchandise exports) of Ghana?
Your response must be concise. -8.01. In the year 2003, what is the difference between the Imports(as % of merchandise exports) of Gambia, The and Imports(as % of merchandise exports) of Yemen, Rep.?
Give a very brief answer. -4.03. In the year 2003, what is the difference between the Imports(as % of merchandise exports) in Ghana and Imports(as % of merchandise exports) in Yemen, Rep.?
Offer a very short reply. 3.99. In the year 2005, what is the difference between the Imports(as % of merchandise exports) in Middle East & North Africa (developing only) and Imports(as % of merchandise exports) in Gambia, The?
Ensure brevity in your answer.  -3.38. In the year 2005, what is the difference between the Imports(as % of merchandise exports) of Middle East & North Africa (developing only) and Imports(as % of merchandise exports) of Ghana?
Provide a short and direct response. -0.97. In the year 2005, what is the difference between the Imports(as % of merchandise exports) in Middle East & North Africa (developing only) and Imports(as % of merchandise exports) in Yemen, Rep.?
Your response must be concise. -6.67. In the year 2005, what is the difference between the Imports(as % of merchandise exports) of Gambia, The and Imports(as % of merchandise exports) of Ghana?
Give a very brief answer. 2.41. In the year 2005, what is the difference between the Imports(as % of merchandise exports) of Gambia, The and Imports(as % of merchandise exports) of Yemen, Rep.?
Keep it short and to the point. -3.29. In the year 2005, what is the difference between the Imports(as % of merchandise exports) of Ghana and Imports(as % of merchandise exports) of Yemen, Rep.?
Offer a very short reply. -5.7. In the year 2006, what is the difference between the Imports(as % of merchandise exports) of Middle East & North Africa (developing only) and Imports(as % of merchandise exports) of Gambia, The?
Offer a very short reply. -3.65. In the year 2006, what is the difference between the Imports(as % of merchandise exports) in Middle East & North Africa (developing only) and Imports(as % of merchandise exports) in Ghana?
Your response must be concise. -0.03. In the year 2006, what is the difference between the Imports(as % of merchandise exports) in Middle East & North Africa (developing only) and Imports(as % of merchandise exports) in Yemen, Rep.?
Make the answer very short. -7.83. In the year 2006, what is the difference between the Imports(as % of merchandise exports) in Gambia, The and Imports(as % of merchandise exports) in Ghana?
Your response must be concise. 3.62. In the year 2006, what is the difference between the Imports(as % of merchandise exports) of Gambia, The and Imports(as % of merchandise exports) of Yemen, Rep.?
Offer a terse response. -4.17. In the year 2006, what is the difference between the Imports(as % of merchandise exports) in Ghana and Imports(as % of merchandise exports) in Yemen, Rep.?
Keep it short and to the point. -7.79. What is the ratio of the Imports(as % of merchandise exports) of Middle East & North Africa (developing only) in 1999 to that in 2000?
Ensure brevity in your answer.  0.9. What is the ratio of the Imports(as % of merchandise exports) of Gambia, The in 1999 to that in 2000?
Ensure brevity in your answer.  0.43. What is the ratio of the Imports(as % of merchandise exports) of Ghana in 1999 to that in 2000?
Provide a short and direct response. 0.83. What is the ratio of the Imports(as % of merchandise exports) in Yemen, Rep. in 1999 to that in 2000?
Make the answer very short. 0.67. What is the ratio of the Imports(as % of merchandise exports) in Middle East & North Africa (developing only) in 1999 to that in 2001?
Keep it short and to the point. 0.83. What is the ratio of the Imports(as % of merchandise exports) of Gambia, The in 1999 to that in 2001?
Your response must be concise. 0.72. What is the ratio of the Imports(as % of merchandise exports) of Ghana in 1999 to that in 2001?
Make the answer very short. 0.78. What is the ratio of the Imports(as % of merchandise exports) in Yemen, Rep. in 1999 to that in 2001?
Ensure brevity in your answer.  0.67. What is the ratio of the Imports(as % of merchandise exports) of Middle East & North Africa (developing only) in 1999 to that in 2002?
Provide a succinct answer. 0.92. What is the ratio of the Imports(as % of merchandise exports) of Gambia, The in 1999 to that in 2002?
Ensure brevity in your answer.  0.48. What is the ratio of the Imports(as % of merchandise exports) of Ghana in 1999 to that in 2002?
Your answer should be compact. 2.07. What is the ratio of the Imports(as % of merchandise exports) of Yemen, Rep. in 1999 to that in 2002?
Keep it short and to the point. 0.55. What is the ratio of the Imports(as % of merchandise exports) of Middle East & North Africa (developing only) in 1999 to that in 2003?
Offer a very short reply. 0.71. What is the ratio of the Imports(as % of merchandise exports) in Gambia, The in 1999 to that in 2003?
Ensure brevity in your answer.  0.48. What is the ratio of the Imports(as % of merchandise exports) of Ghana in 1999 to that in 2003?
Give a very brief answer. 0.95. What is the ratio of the Imports(as % of merchandise exports) in Yemen, Rep. in 1999 to that in 2003?
Your answer should be compact. 0.55. What is the ratio of the Imports(as % of merchandise exports) in Middle East & North Africa (developing only) in 1999 to that in 2005?
Provide a succinct answer. 0.45. What is the ratio of the Imports(as % of merchandise exports) of Gambia, The in 1999 to that in 2005?
Your answer should be compact. 0.32. What is the ratio of the Imports(as % of merchandise exports) of Ghana in 1999 to that in 2005?
Keep it short and to the point. 1.3. What is the ratio of the Imports(as % of merchandise exports) in Yemen, Rep. in 1999 to that in 2005?
Your answer should be very brief. 0.42. What is the ratio of the Imports(as % of merchandise exports) of Middle East & North Africa (developing only) in 1999 to that in 2006?
Provide a succinct answer. 0.42. What is the ratio of the Imports(as % of merchandise exports) in Gambia, The in 1999 to that in 2006?
Keep it short and to the point. 0.29. What is the ratio of the Imports(as % of merchandise exports) of Ghana in 1999 to that in 2006?
Make the answer very short. 1.29. What is the ratio of the Imports(as % of merchandise exports) in Yemen, Rep. in 1999 to that in 2006?
Give a very brief answer. 0.37. What is the ratio of the Imports(as % of merchandise exports) in Middle East & North Africa (developing only) in 2000 to that in 2001?
Give a very brief answer. 0.93. What is the ratio of the Imports(as % of merchandise exports) of Gambia, The in 2000 to that in 2001?
Your response must be concise. 1.69. What is the ratio of the Imports(as % of merchandise exports) of Ghana in 2000 to that in 2001?
Offer a very short reply. 0.95. What is the ratio of the Imports(as % of merchandise exports) of Middle East & North Africa (developing only) in 2000 to that in 2002?
Your answer should be very brief. 1.03. What is the ratio of the Imports(as % of merchandise exports) of Gambia, The in 2000 to that in 2002?
Provide a succinct answer. 1.13. What is the ratio of the Imports(as % of merchandise exports) in Ghana in 2000 to that in 2002?
Provide a short and direct response. 2.5. What is the ratio of the Imports(as % of merchandise exports) in Yemen, Rep. in 2000 to that in 2002?
Provide a short and direct response. 0.82. What is the ratio of the Imports(as % of merchandise exports) in Middle East & North Africa (developing only) in 2000 to that in 2003?
Give a very brief answer. 0.79. What is the ratio of the Imports(as % of merchandise exports) of Gambia, The in 2000 to that in 2003?
Offer a terse response. 1.13. What is the ratio of the Imports(as % of merchandise exports) of Ghana in 2000 to that in 2003?
Give a very brief answer. 1.15. What is the ratio of the Imports(as % of merchandise exports) in Yemen, Rep. in 2000 to that in 2003?
Make the answer very short. 0.82. What is the ratio of the Imports(as % of merchandise exports) of Middle East & North Africa (developing only) in 2000 to that in 2005?
Provide a short and direct response. 0.5. What is the ratio of the Imports(as % of merchandise exports) in Gambia, The in 2000 to that in 2005?
Keep it short and to the point. 0.74. What is the ratio of the Imports(as % of merchandise exports) of Ghana in 2000 to that in 2005?
Your answer should be very brief. 1.57. What is the ratio of the Imports(as % of merchandise exports) of Yemen, Rep. in 2000 to that in 2005?
Make the answer very short. 0.62. What is the ratio of the Imports(as % of merchandise exports) in Middle East & North Africa (developing only) in 2000 to that in 2006?
Keep it short and to the point. 0.47. What is the ratio of the Imports(as % of merchandise exports) in Gambia, The in 2000 to that in 2006?
Provide a short and direct response. 0.69. What is the ratio of the Imports(as % of merchandise exports) in Ghana in 2000 to that in 2006?
Provide a succinct answer. 1.56. What is the ratio of the Imports(as % of merchandise exports) of Yemen, Rep. in 2000 to that in 2006?
Provide a short and direct response. 0.55. What is the ratio of the Imports(as % of merchandise exports) in Middle East & North Africa (developing only) in 2001 to that in 2002?
Make the answer very short. 1.11. What is the ratio of the Imports(as % of merchandise exports) of Gambia, The in 2001 to that in 2002?
Provide a short and direct response. 0.67. What is the ratio of the Imports(as % of merchandise exports) in Ghana in 2001 to that in 2002?
Your answer should be very brief. 2.64. What is the ratio of the Imports(as % of merchandise exports) in Yemen, Rep. in 2001 to that in 2002?
Offer a very short reply. 0.82. What is the ratio of the Imports(as % of merchandise exports) of Middle East & North Africa (developing only) in 2001 to that in 2003?
Keep it short and to the point. 0.85. What is the ratio of the Imports(as % of merchandise exports) in Gambia, The in 2001 to that in 2003?
Make the answer very short. 0.67. What is the ratio of the Imports(as % of merchandise exports) in Ghana in 2001 to that in 2003?
Your answer should be compact. 1.22. What is the ratio of the Imports(as % of merchandise exports) in Yemen, Rep. in 2001 to that in 2003?
Your answer should be very brief. 0.82. What is the ratio of the Imports(as % of merchandise exports) of Middle East & North Africa (developing only) in 2001 to that in 2005?
Make the answer very short. 0.54. What is the ratio of the Imports(as % of merchandise exports) in Gambia, The in 2001 to that in 2005?
Offer a very short reply. 0.44. What is the ratio of the Imports(as % of merchandise exports) of Ghana in 2001 to that in 2005?
Make the answer very short. 1.66. What is the ratio of the Imports(as % of merchandise exports) of Yemen, Rep. in 2001 to that in 2005?
Give a very brief answer. 0.62. What is the ratio of the Imports(as % of merchandise exports) of Middle East & North Africa (developing only) in 2001 to that in 2006?
Make the answer very short. 0.5. What is the ratio of the Imports(as % of merchandise exports) in Gambia, The in 2001 to that in 2006?
Your response must be concise. 0.41. What is the ratio of the Imports(as % of merchandise exports) of Ghana in 2001 to that in 2006?
Provide a short and direct response. 1.65. What is the ratio of the Imports(as % of merchandise exports) in Yemen, Rep. in 2001 to that in 2006?
Give a very brief answer. 0.56. What is the ratio of the Imports(as % of merchandise exports) of Middle East & North Africa (developing only) in 2002 to that in 2003?
Provide a succinct answer. 0.77. What is the ratio of the Imports(as % of merchandise exports) in Ghana in 2002 to that in 2003?
Keep it short and to the point. 0.46. What is the ratio of the Imports(as % of merchandise exports) of Yemen, Rep. in 2002 to that in 2003?
Make the answer very short. 1. What is the ratio of the Imports(as % of merchandise exports) in Middle East & North Africa (developing only) in 2002 to that in 2005?
Provide a succinct answer. 0.49. What is the ratio of the Imports(as % of merchandise exports) in Gambia, The in 2002 to that in 2005?
Provide a succinct answer. 0.66. What is the ratio of the Imports(as % of merchandise exports) in Ghana in 2002 to that in 2005?
Offer a terse response. 0.63. What is the ratio of the Imports(as % of merchandise exports) in Yemen, Rep. in 2002 to that in 2005?
Provide a succinct answer. 0.76. What is the ratio of the Imports(as % of merchandise exports) in Middle East & North Africa (developing only) in 2002 to that in 2006?
Offer a very short reply. 0.45. What is the ratio of the Imports(as % of merchandise exports) of Gambia, The in 2002 to that in 2006?
Make the answer very short. 0.61. What is the ratio of the Imports(as % of merchandise exports) of Ghana in 2002 to that in 2006?
Give a very brief answer. 0.62. What is the ratio of the Imports(as % of merchandise exports) of Yemen, Rep. in 2002 to that in 2006?
Offer a very short reply. 0.68. What is the ratio of the Imports(as % of merchandise exports) of Middle East & North Africa (developing only) in 2003 to that in 2005?
Your answer should be compact. 0.64. What is the ratio of the Imports(as % of merchandise exports) in Gambia, The in 2003 to that in 2005?
Your answer should be compact. 0.66. What is the ratio of the Imports(as % of merchandise exports) in Ghana in 2003 to that in 2005?
Keep it short and to the point. 1.36. What is the ratio of the Imports(as % of merchandise exports) of Yemen, Rep. in 2003 to that in 2005?
Offer a very short reply. 0.76. What is the ratio of the Imports(as % of merchandise exports) of Middle East & North Africa (developing only) in 2003 to that in 2006?
Keep it short and to the point. 0.59. What is the ratio of the Imports(as % of merchandise exports) of Gambia, The in 2003 to that in 2006?
Provide a succinct answer. 0.61. What is the ratio of the Imports(as % of merchandise exports) in Ghana in 2003 to that in 2006?
Your answer should be very brief. 1.35. What is the ratio of the Imports(as % of merchandise exports) in Yemen, Rep. in 2003 to that in 2006?
Keep it short and to the point. 0.68. What is the ratio of the Imports(as % of merchandise exports) of Middle East & North Africa (developing only) in 2005 to that in 2006?
Give a very brief answer. 0.92. What is the ratio of the Imports(as % of merchandise exports) of Gambia, The in 2005 to that in 2006?
Your response must be concise. 0.92. What is the ratio of the Imports(as % of merchandise exports) of Ghana in 2005 to that in 2006?
Provide a short and direct response. 0.99. What is the ratio of the Imports(as % of merchandise exports) in Yemen, Rep. in 2005 to that in 2006?
Ensure brevity in your answer.  0.9. What is the difference between the highest and the second highest Imports(as % of merchandise exports) in Middle East & North Africa (developing only)?
Provide a short and direct response. 1.06. What is the difference between the highest and the second highest Imports(as % of merchandise exports) of Gambia, The?
Ensure brevity in your answer.  1.33. What is the difference between the highest and the second highest Imports(as % of merchandise exports) in Ghana?
Ensure brevity in your answer.  1.24. What is the difference between the highest and the second highest Imports(as % of merchandise exports) of Yemen, Rep.?
Provide a succinct answer. 2.21. What is the difference between the highest and the lowest Imports(as % of merchandise exports) in Middle East & North Africa (developing only)?
Offer a terse response. 8.01. What is the difference between the highest and the lowest Imports(as % of merchandise exports) of Gambia, The?
Offer a terse response. 12.27. What is the difference between the highest and the lowest Imports(as % of merchandise exports) in Ghana?
Your answer should be compact. 14.11. What is the difference between the highest and the lowest Imports(as % of merchandise exports) of Yemen, Rep.?
Provide a short and direct response. 13.51. 